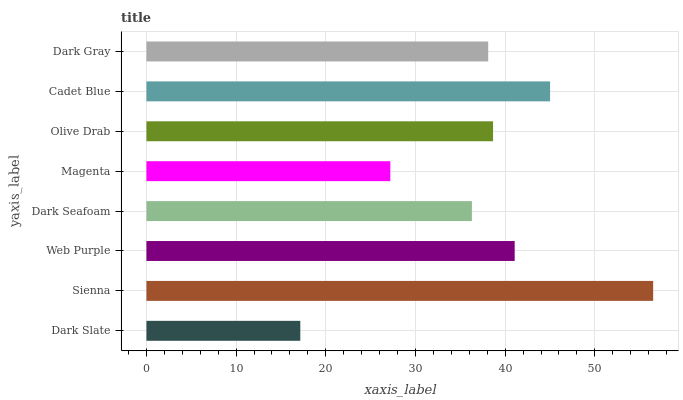Is Dark Slate the minimum?
Answer yes or no. Yes. Is Sienna the maximum?
Answer yes or no. Yes. Is Web Purple the minimum?
Answer yes or no. No. Is Web Purple the maximum?
Answer yes or no. No. Is Sienna greater than Web Purple?
Answer yes or no. Yes. Is Web Purple less than Sienna?
Answer yes or no. Yes. Is Web Purple greater than Sienna?
Answer yes or no. No. Is Sienna less than Web Purple?
Answer yes or no. No. Is Olive Drab the high median?
Answer yes or no. Yes. Is Dark Gray the low median?
Answer yes or no. Yes. Is Dark Slate the high median?
Answer yes or no. No. Is Sienna the low median?
Answer yes or no. No. 